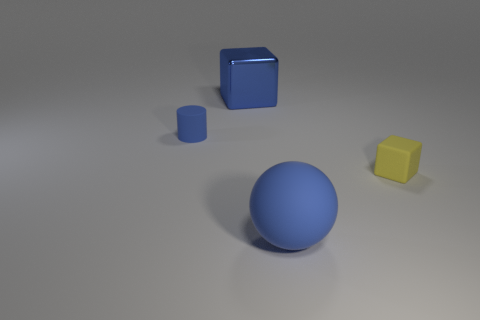Add 3 gray rubber balls. How many objects exist? 7 Subtract all balls. How many objects are left? 3 Subtract 0 green cylinders. How many objects are left? 4 Subtract all small blocks. Subtract all tiny yellow matte things. How many objects are left? 2 Add 3 big blue matte balls. How many big blue matte balls are left? 4 Add 4 small purple cubes. How many small purple cubes exist? 4 